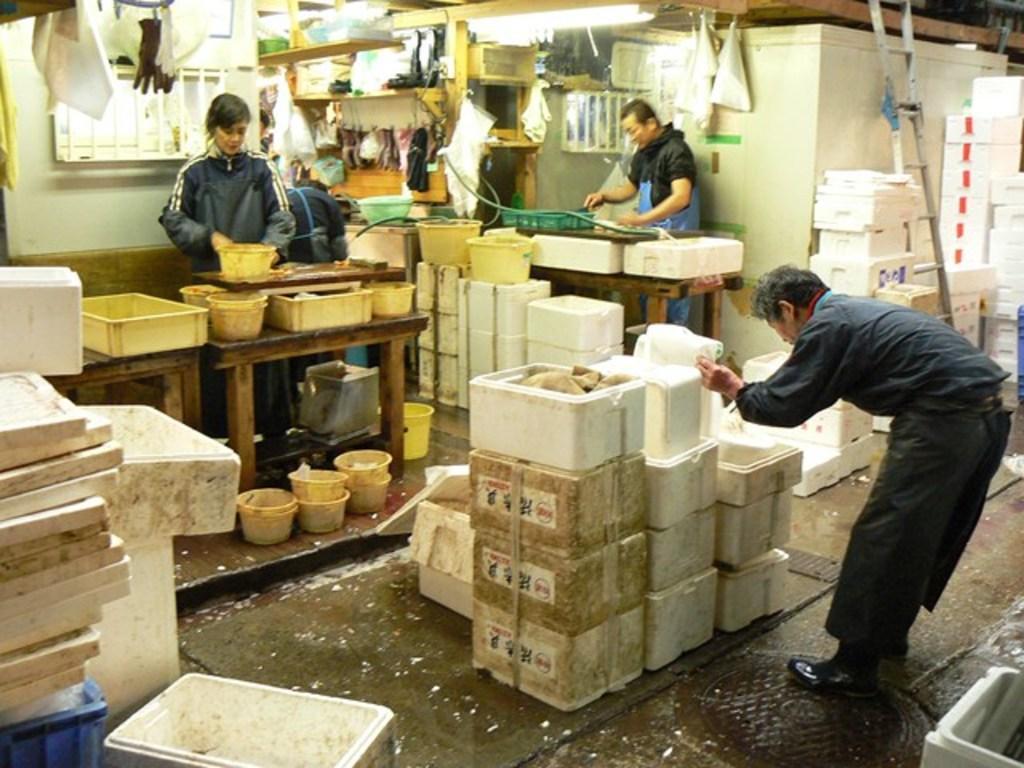Could you give a brief overview of what you see in this image? In this image we can see three persons, boxes, baskets, bowls, tables, gloves, and objects. In the background we can see wall. 